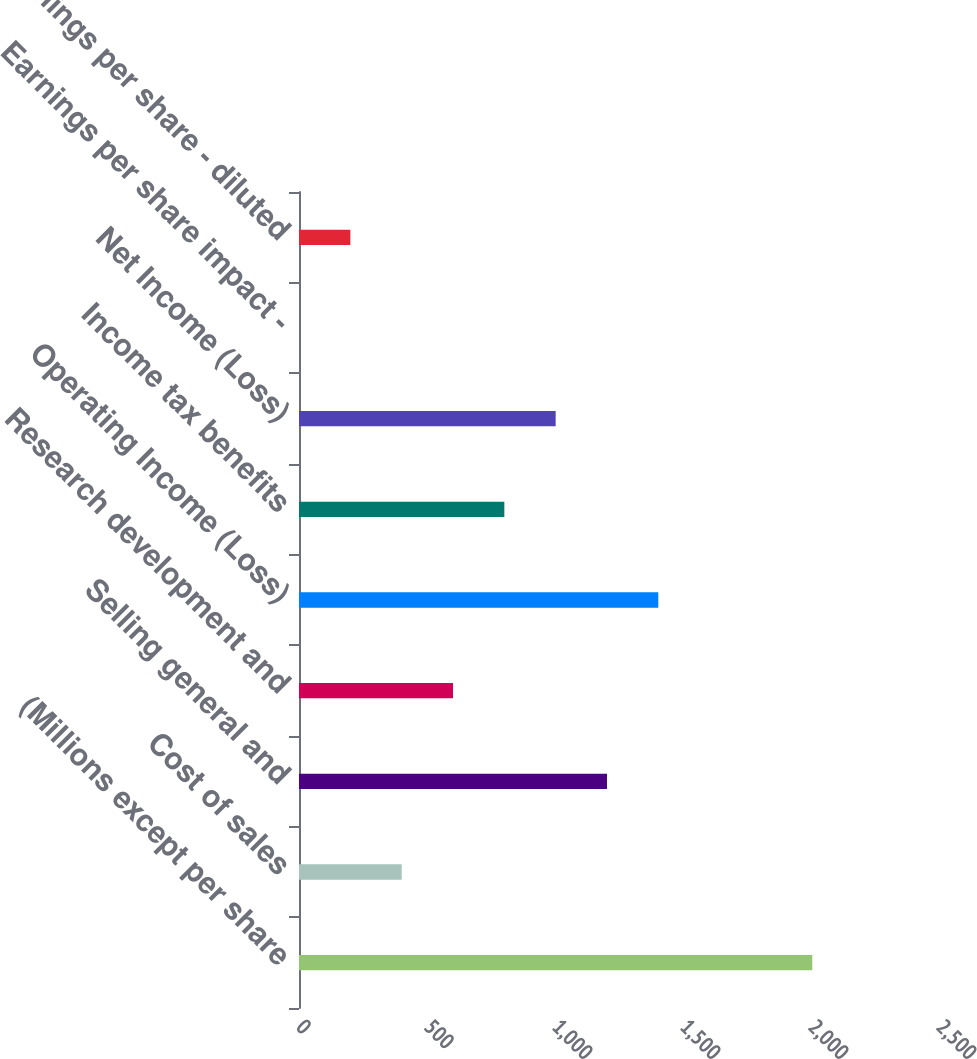<chart> <loc_0><loc_0><loc_500><loc_500><bar_chart><fcel>(Millions except per share<fcel>Cost of sales<fcel>Selling general and<fcel>Research development and<fcel>Operating Income (Loss)<fcel>Income tax benefits<fcel>Net Income (Loss)<fcel>Earnings per share impact -<fcel>Earnings per share - diluted<nl><fcel>2005<fcel>401.12<fcel>1203.08<fcel>601.61<fcel>1403.57<fcel>802.1<fcel>1002.59<fcel>0.14<fcel>200.63<nl></chart> 